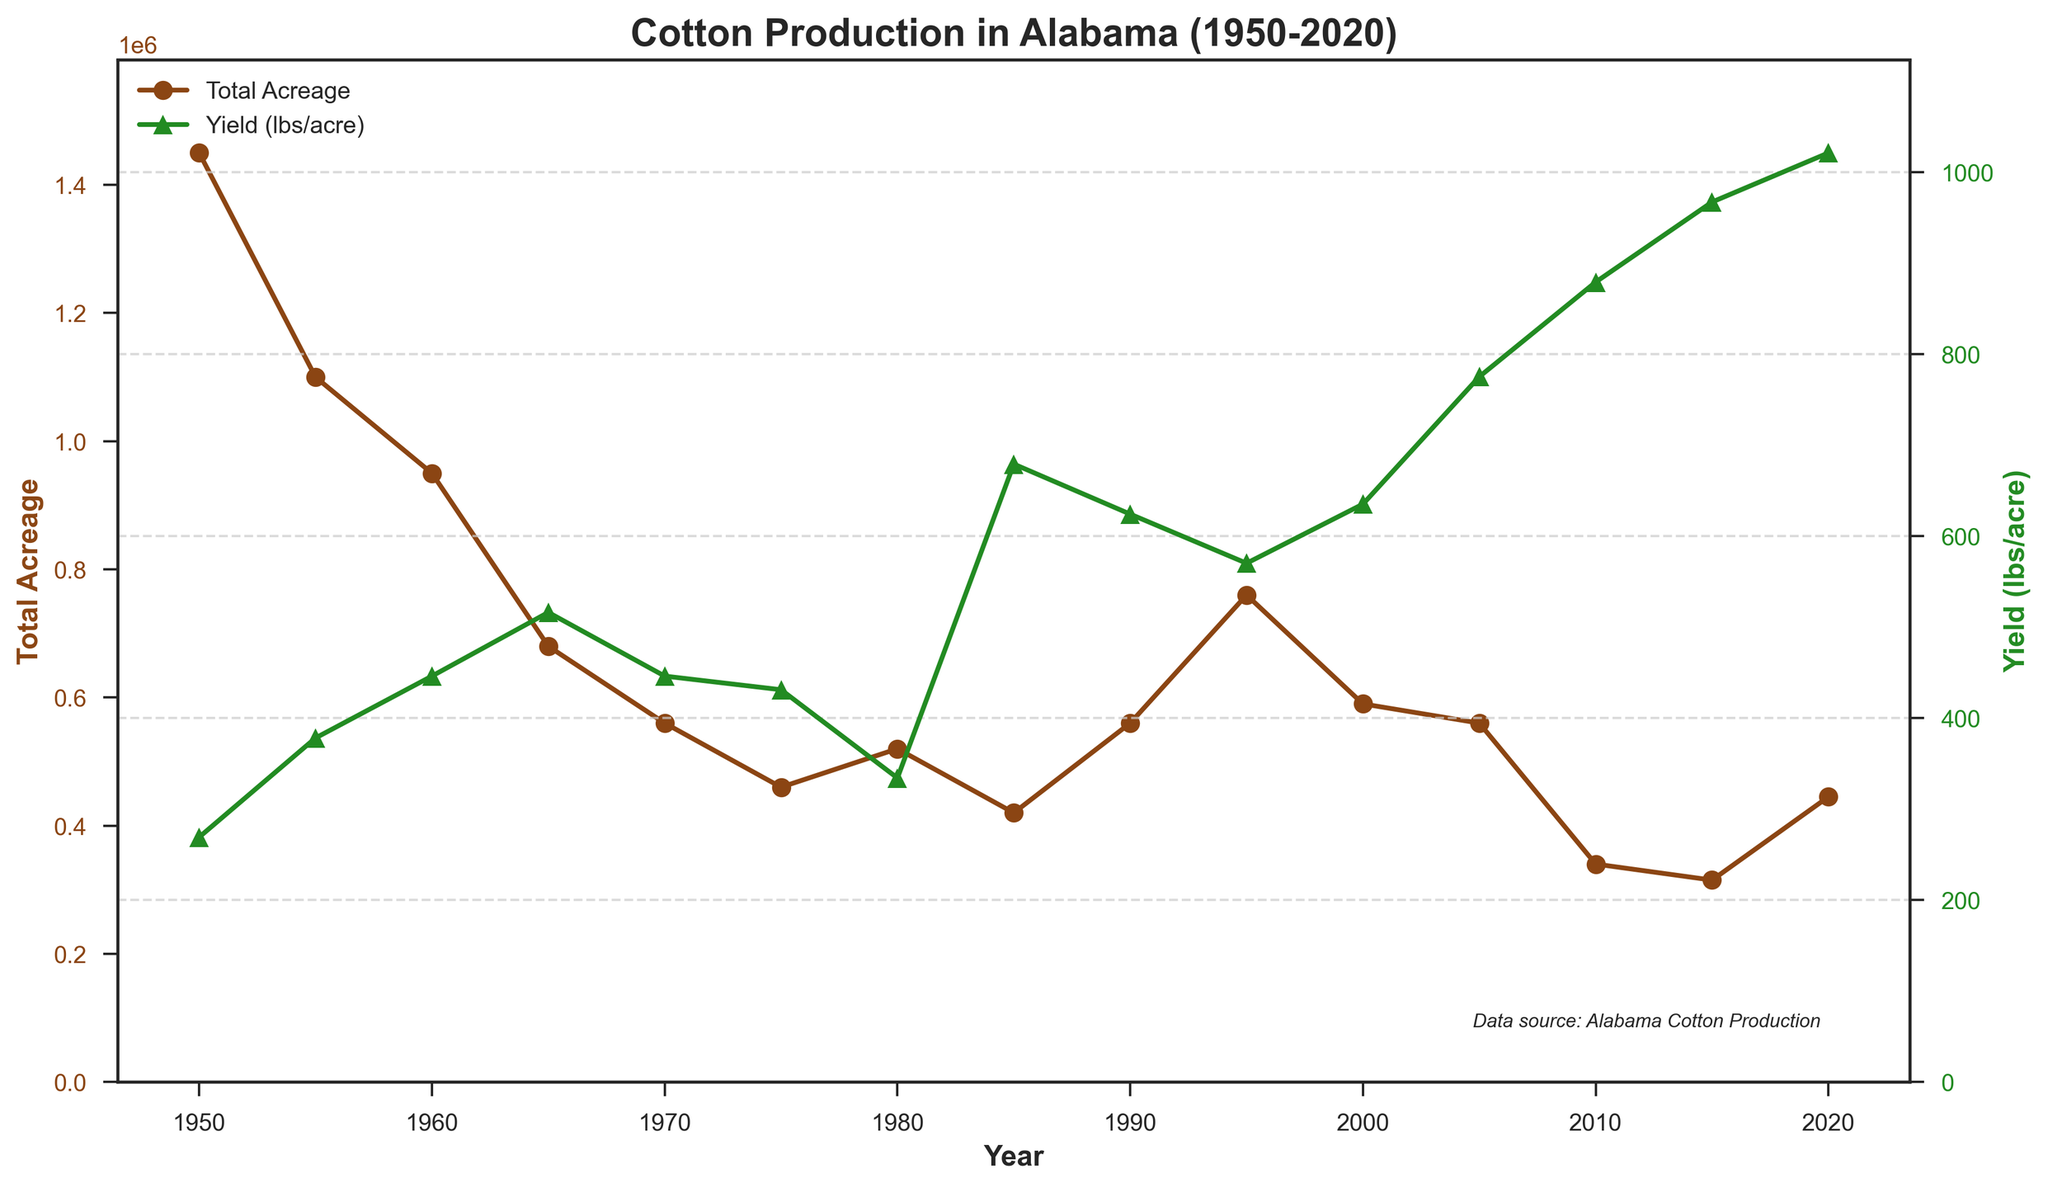What is the overall trend in Total Acreage from 1950 to 2020? The Total Acreage generally shows a downward trend from 1950 with slight fluctuations. Starting at 1,450,000 acres in 1950, it decreases to 445,000 acres by 2020.
Answer: Downward During which year does Yield (lbs/acre) reach its peak, and what is the value? Yield reaches its peak in 2020 with a value of 1021 lbs/acre. This can be observed as the highest point on the Yield (lbs/acre) line with a marker in 2020.
Answer: 2020, 1021 lbs/acre Compare the Total Production in the years 1955 and 2015. Which year had a higher Total Production? In 1955, the Total Production was 865,000 bales. In 2015, it was 635,000 bales. Comparing these values, 1955 had a higher Total Production.
Answer: 1955 What is the difference in Total Acreage between 1980 and 2000? In 1980, the Total Acreage was 520,000 acres. In 2000, it was 590,000 acres. The difference is 590,000 - 520,000 = 70,000 acres.
Answer: 70,000 acres How does the trend in Yield (lbs/acre) compare with the trend in Total Acreage over the period shown? The Yield generally increases over time while the Total Acreage generally decreases. This indicates an inverse relationship between the two over the period shown.
Answer: Inverse Relationship What was the Yield (lbs/acre) in the year 1970 and how does it compare to the Yield in the year 2000? In 1970, the Yield was 446 lbs/acre. In 2000, the Yield was 635 lbs/acre. Comparing these values, the Yield in 2000 was higher by 635 - 446 = 189 lbs/acre.
Answer: 2000 was 189 lbs/acre higher What can you infer about the productivity of cotton farming in Alabama based on the trends in Yield and Total Acreage? Despite the reduction in Total Acreage, the Yield per acre has increased significantly, suggesting improvements in farming techniques and productivity.
Answer: Increased Productivity In which year did the Total Acreage dip to its lowest, according to the line chart? The Total Acreage dipped to its lowest at 315,000 acres in the year 2015. This is the lowest point on the Total Acreage line observed in the chart.
Answer: 2015 Calculate the average Yield (lbs/acre) over the 70-year period. Adding the Yield values for each year from the data: 269 + 378 + 446 + 516 + 446 + 431 + 334 + 679 + 624 + 570 + 635 + 775 + 879 + 967 + 1021 = 8970 lbs. Dividing by the number of years (15), the average Yield is 8970 / 15 = 598 lbs/acre.
Answer: 598 lbs/acre 